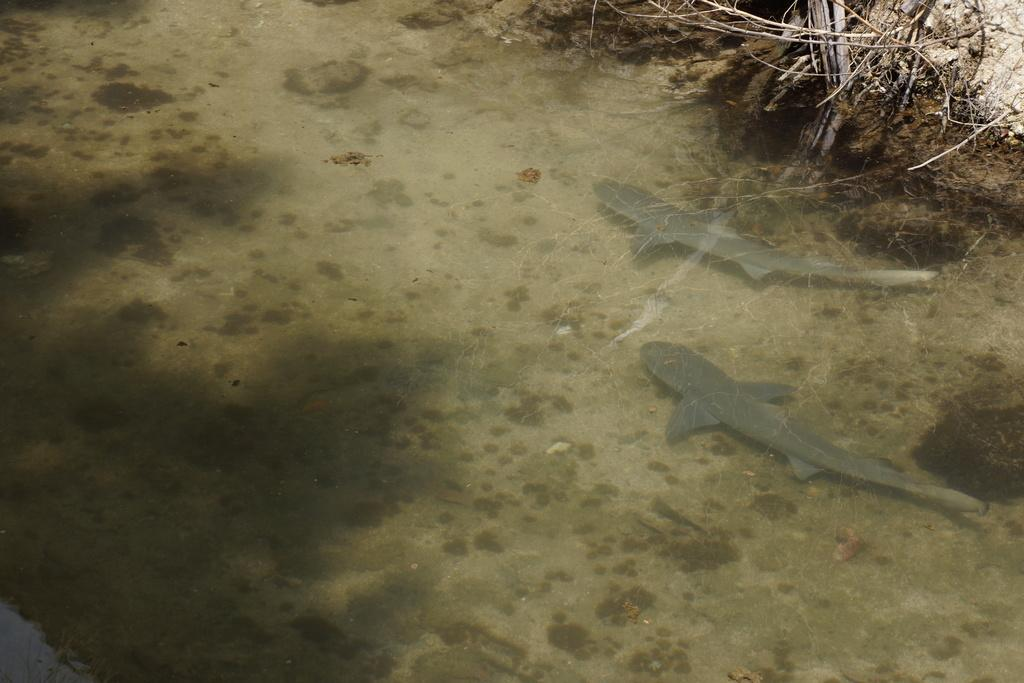What is the primary element in the image? There is water in the image. What can be seen swimming in the water? There are two gray-colored fishes in the water. What type of path is visible in the image? There is a mud path visible in the image. What is located near the mud path? There are twigs near the mud path. Can you tell me how the snake is helping the fishes in the image? There is no snake present in the image, so it cannot be helping the fishes. 